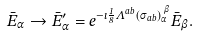Convert formula to latex. <formula><loc_0><loc_0><loc_500><loc_500>\bar { E } _ { \alpha } \rightarrow \bar { E } ^ { \prime } _ { \alpha } = e ^ { - \imath \frac { 1 } { 8 } \Lambda ^ { a b } ( \sigma _ { a b } ) _ { \alpha } ^ { \, \beta } } \bar { E } _ { \beta } .</formula> 